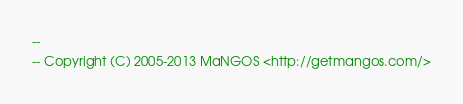Convert code to text. <code><loc_0><loc_0><loc_500><loc_500><_SQL_>--
-- Copyright (C) 2005-2013 MaNGOS <http://getmangos.com/></code> 